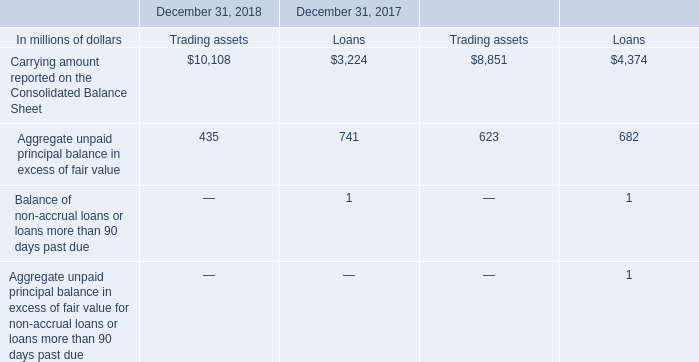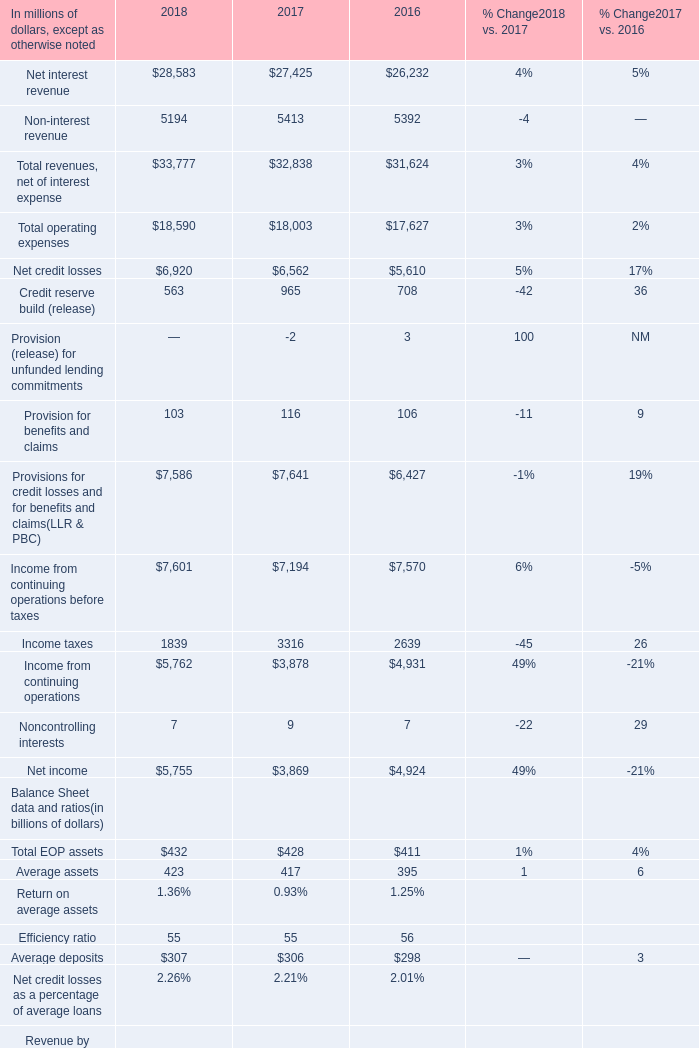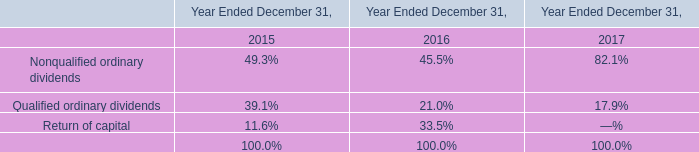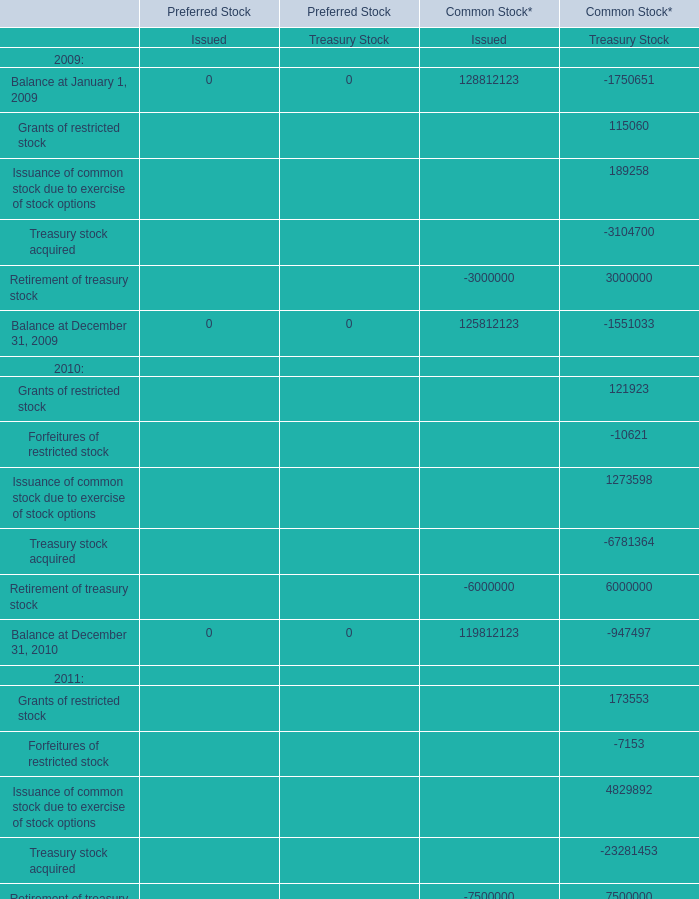what's the total amount of Net credit losses of 2018, Balance at January 1, 2009 of Common Stock* Treasury Stock, and Carrying amount reported on the Consolidated Balance Sheet of December 31, 2017 Loans ? 
Computations: ((6920.0 + 1750651.0) + 3224.0)
Answer: 1760795.0. 